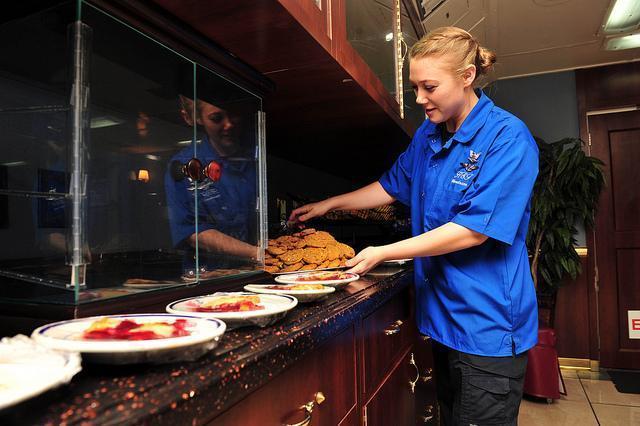How many people are there?
Give a very brief answer. 1. 